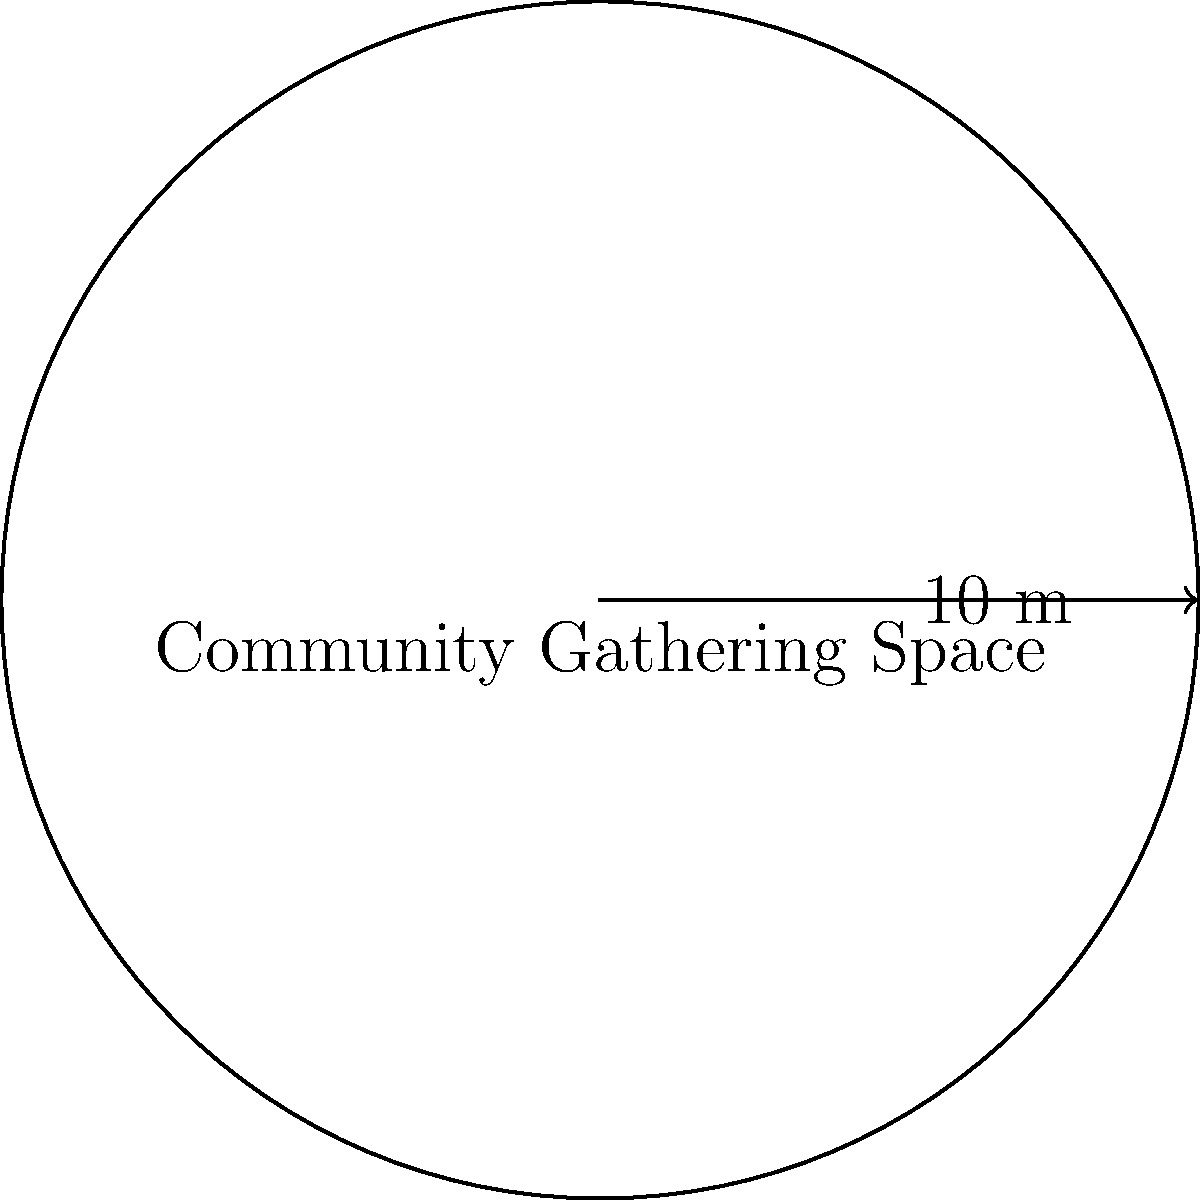A new community gathering space is being designed for immigrants to meet and share cultural experiences. The space will be circular with a radius of 10 meters. What is the area of this gathering space in square meters? (Use $\pi \approx 3.14$) To find the area of a circular space, we use the formula:

$A = \pi r^2$

Where:
$A$ = Area
$\pi$ = Pi (approximately 3.14)
$r$ = Radius

Given:
Radius ($r$) = 10 meters
$\pi \approx 3.14$

Step 1: Substitute the values into the formula
$A = \pi r^2$
$A = 3.14 \times 10^2$

Step 2: Calculate the square of the radius
$A = 3.14 \times 100$

Step 3: Multiply
$A = 314$ square meters

Therefore, the area of the circular community gathering space is 314 square meters.
Answer: 314 m² 